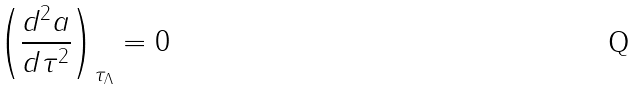Convert formula to latex. <formula><loc_0><loc_0><loc_500><loc_500>\left ( \frac { d ^ { 2 } a } { d \tau ^ { 2 } } \right ) _ { \tau _ { \Lambda } } = 0</formula> 